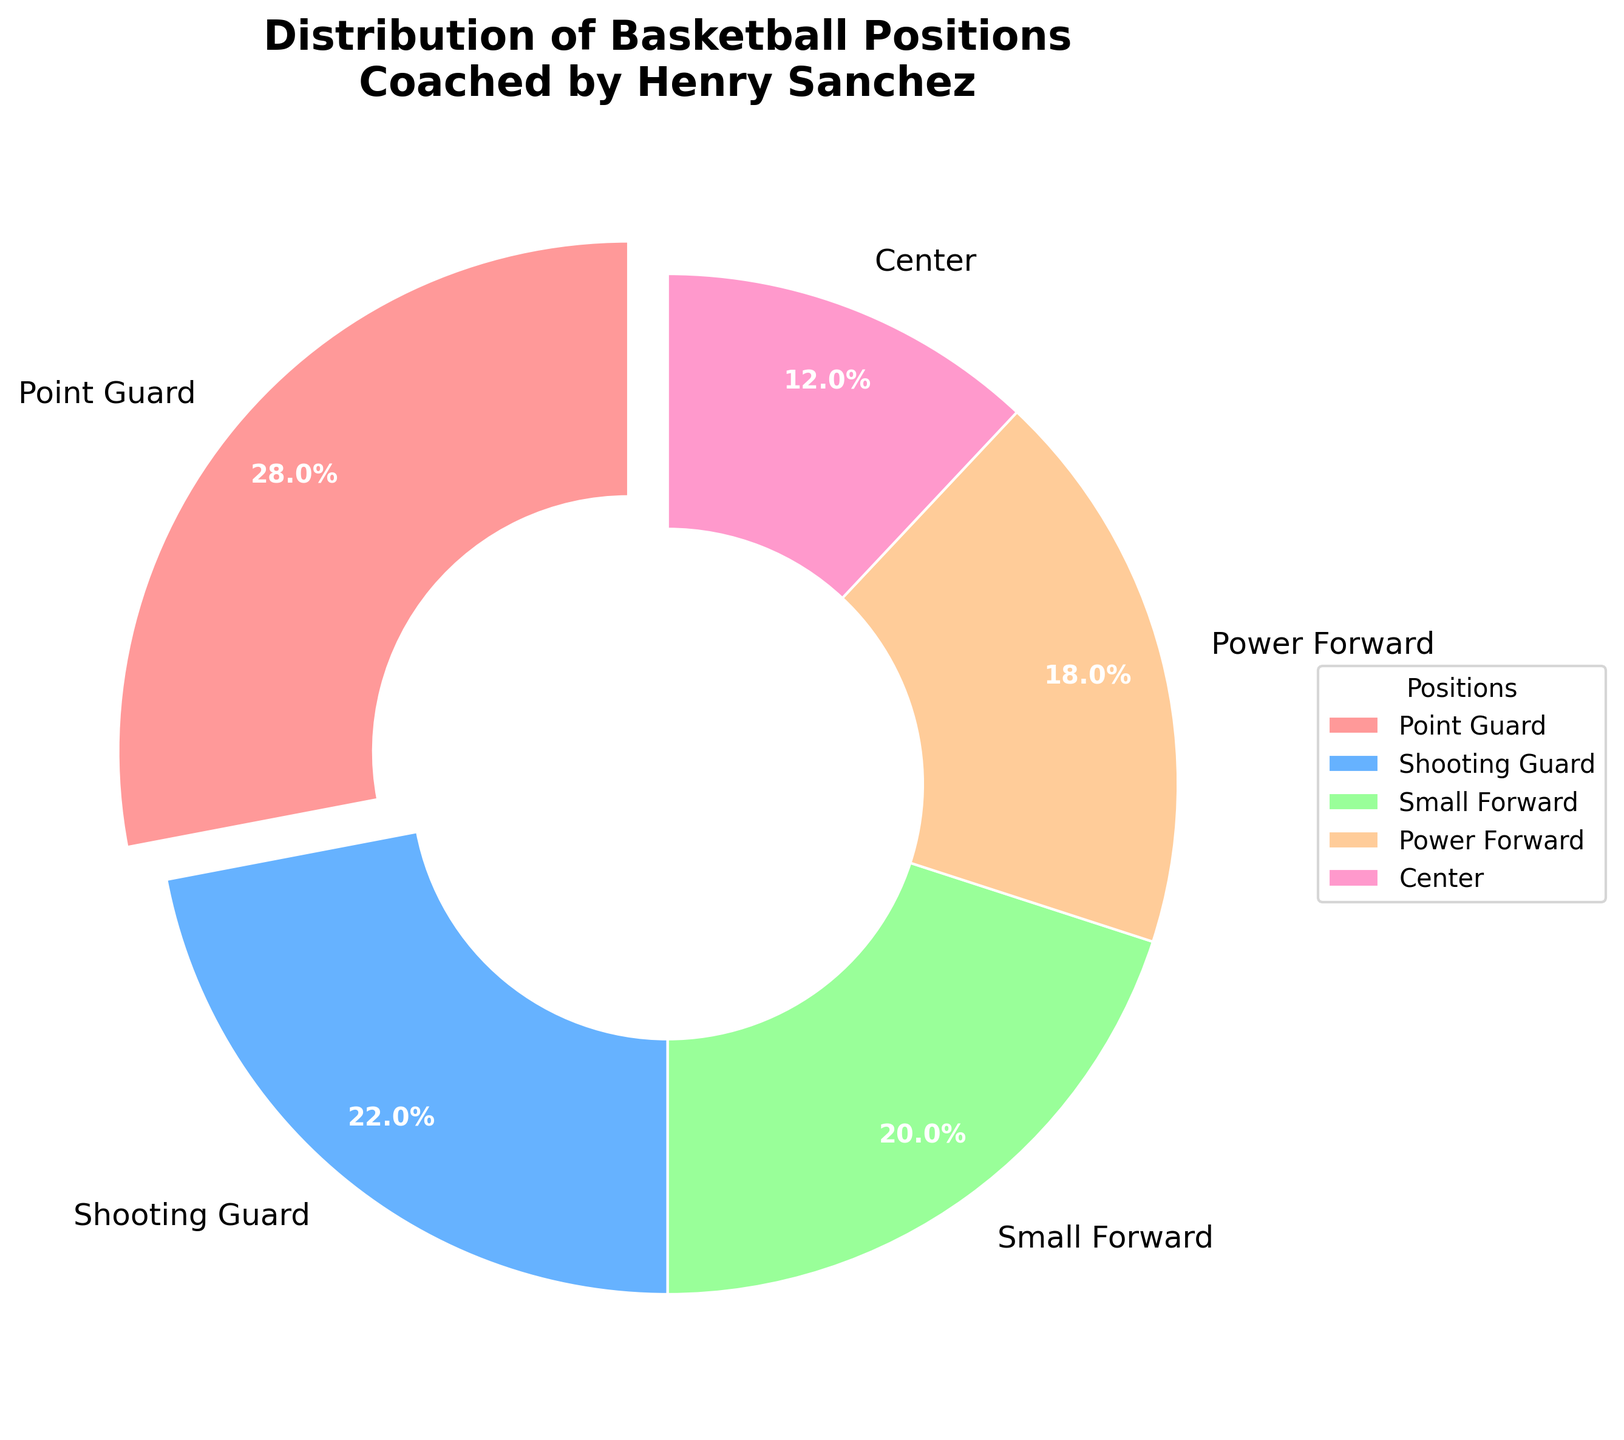What's the most common position played by Henry Sanchez's former players? The most common position can be identified by finding the segment with the largest percentage. In this case, it is the "Point Guard" position at 28%.
Answer: Point Guard What's the percentage difference between players who played as Shooting Guard and those who played as Center? Subtract the percentage of Centers (12%) from the percentage of Shooting Guards (22%). 22% - 12% = 10%.
Answer: 10% What's the combined percentage of former players who played as Power Forward and Center? Add the percentages of Power Forwards (18%) and Centers (12%). 18% + 12% = 30%.
Answer: 30% Which position has the smallest percentage of players? The position with the smallest segment in the pie chart is "Center" with 12%.
Answer: Center Are there more players who played as Small Forward or Power Forward? Compare the percentages of Small Forwards (20%) and Power Forwards (18%). Small Forwards have a higher percentage.
Answer: Small Forward What is the sum of percentages for guards (Point Guard and Shooting Guard)? Add the percentages of Point Guards (28%) and Shooting Guards (22%). 28% + 22% = 50%.
Answer: 50% Which position has the second largest percentage of players? Look for the second largest segment after Point Guard (28%). The second largest is Shooting Guard with 22%.
Answer: Shooting Guard What is the approximate percentage of players who did not play as guards (neither Point Guard nor Shooting Guard)? Sum the percentages of Small Forward (20%), Power Forward (18%), and Center (12%). 20% + 18% + 12% = 50%.
Answer: 50% If the chart has a title, what is it? The title of the pie chart is displayed above it and reads "Distribution of Basketball Positions Coached by Henry Sanchez".
Answer: Distribution of Basketball Positions Coached by Henry Sanchez Which color represents the "Small Forward" position in the chart? Identify the color of the segment labeled "Small Forward" in the pie chart. The color is light green.
Answer: light green 